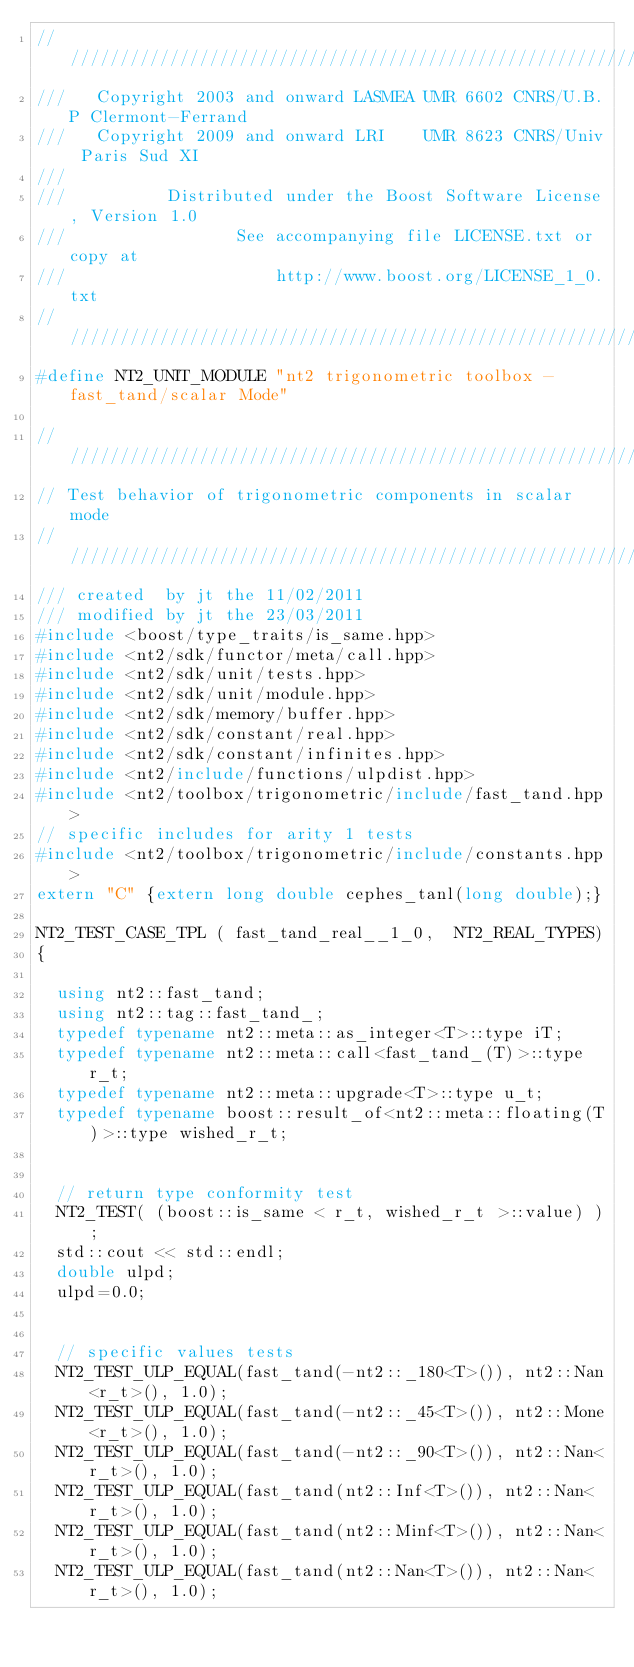Convert code to text. <code><loc_0><loc_0><loc_500><loc_500><_C++_>//////////////////////////////////////////////////////////////////////////////
///   Copyright 2003 and onward LASMEA UMR 6602 CNRS/U.B.P Clermont-Ferrand
///   Copyright 2009 and onward LRI    UMR 8623 CNRS/Univ Paris Sud XI
///
///          Distributed under the Boost Software License, Version 1.0
///                 See accompanying file LICENSE.txt or copy at
///                     http://www.boost.org/LICENSE_1_0.txt
//////////////////////////////////////////////////////////////////////////////
#define NT2_UNIT_MODULE "nt2 trigonometric toolbox - fast_tand/scalar Mode"

//////////////////////////////////////////////////////////////////////////////
// Test behavior of trigonometric components in scalar mode
//////////////////////////////////////////////////////////////////////////////
/// created  by jt the 11/02/2011
/// modified by jt the 23/03/2011
#include <boost/type_traits/is_same.hpp>
#include <nt2/sdk/functor/meta/call.hpp>
#include <nt2/sdk/unit/tests.hpp>
#include <nt2/sdk/unit/module.hpp>
#include <nt2/sdk/memory/buffer.hpp>
#include <nt2/sdk/constant/real.hpp>
#include <nt2/sdk/constant/infinites.hpp>
#include <nt2/include/functions/ulpdist.hpp>
#include <nt2/toolbox/trigonometric/include/fast_tand.hpp>
// specific includes for arity 1 tests
#include <nt2/toolbox/trigonometric/include/constants.hpp>
extern "C" {extern long double cephes_tanl(long double);}

NT2_TEST_CASE_TPL ( fast_tand_real__1_0,  NT2_REAL_TYPES)
{
  
  using nt2::fast_tand;
  using nt2::tag::fast_tand_;
  typedef typename nt2::meta::as_integer<T>::type iT;
  typedef typename nt2::meta::call<fast_tand_(T)>::type r_t;
  typedef typename nt2::meta::upgrade<T>::type u_t;
  typedef typename boost::result_of<nt2::meta::floating(T)>::type wished_r_t;


  // return type conformity test 
  NT2_TEST( (boost::is_same < r_t, wished_r_t >::value) );
  std::cout << std::endl; 
  double ulpd;
  ulpd=0.0;


  // specific values tests
  NT2_TEST_ULP_EQUAL(fast_tand(-nt2::_180<T>()), nt2::Nan<r_t>(), 1.0);
  NT2_TEST_ULP_EQUAL(fast_tand(-nt2::_45<T>()), nt2::Mone<r_t>(), 1.0);
  NT2_TEST_ULP_EQUAL(fast_tand(-nt2::_90<T>()), nt2::Nan<r_t>(), 1.0);
  NT2_TEST_ULP_EQUAL(fast_tand(nt2::Inf<T>()), nt2::Nan<r_t>(), 1.0);
  NT2_TEST_ULP_EQUAL(fast_tand(nt2::Minf<T>()), nt2::Nan<r_t>(), 1.0);
  NT2_TEST_ULP_EQUAL(fast_tand(nt2::Nan<T>()), nt2::Nan<r_t>(), 1.0);</code> 